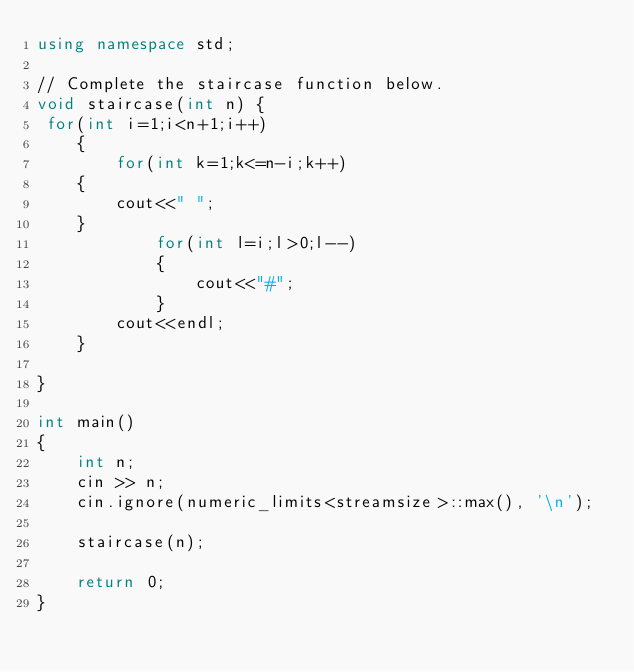Convert code to text. <code><loc_0><loc_0><loc_500><loc_500><_C++_>using namespace std;

// Complete the staircase function below.
void staircase(int n) {
 for(int i=1;i<n+1;i++)
    {
        for(int k=1;k<=n-i;k++)
    {
        cout<<" ";
    }
            for(int l=i;l>0;l--)
            {
                cout<<"#";
            }
        cout<<endl;
    }

}

int main()
{
    int n;
    cin >> n;
    cin.ignore(numeric_limits<streamsize>::max(), '\n');

    staircase(n);

    return 0;
}

</code> 